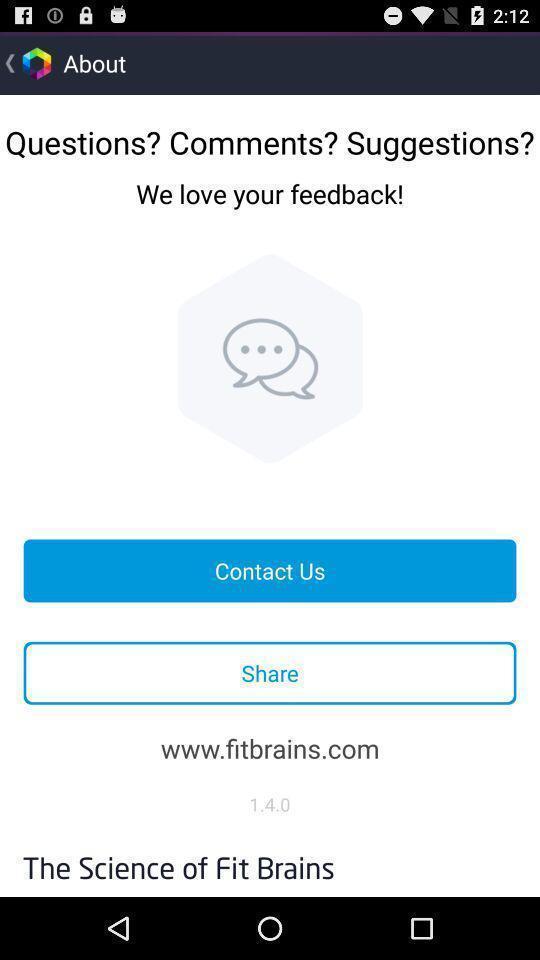Explain what's happening in this screen capture. Screen displaying multiple feedback options. 